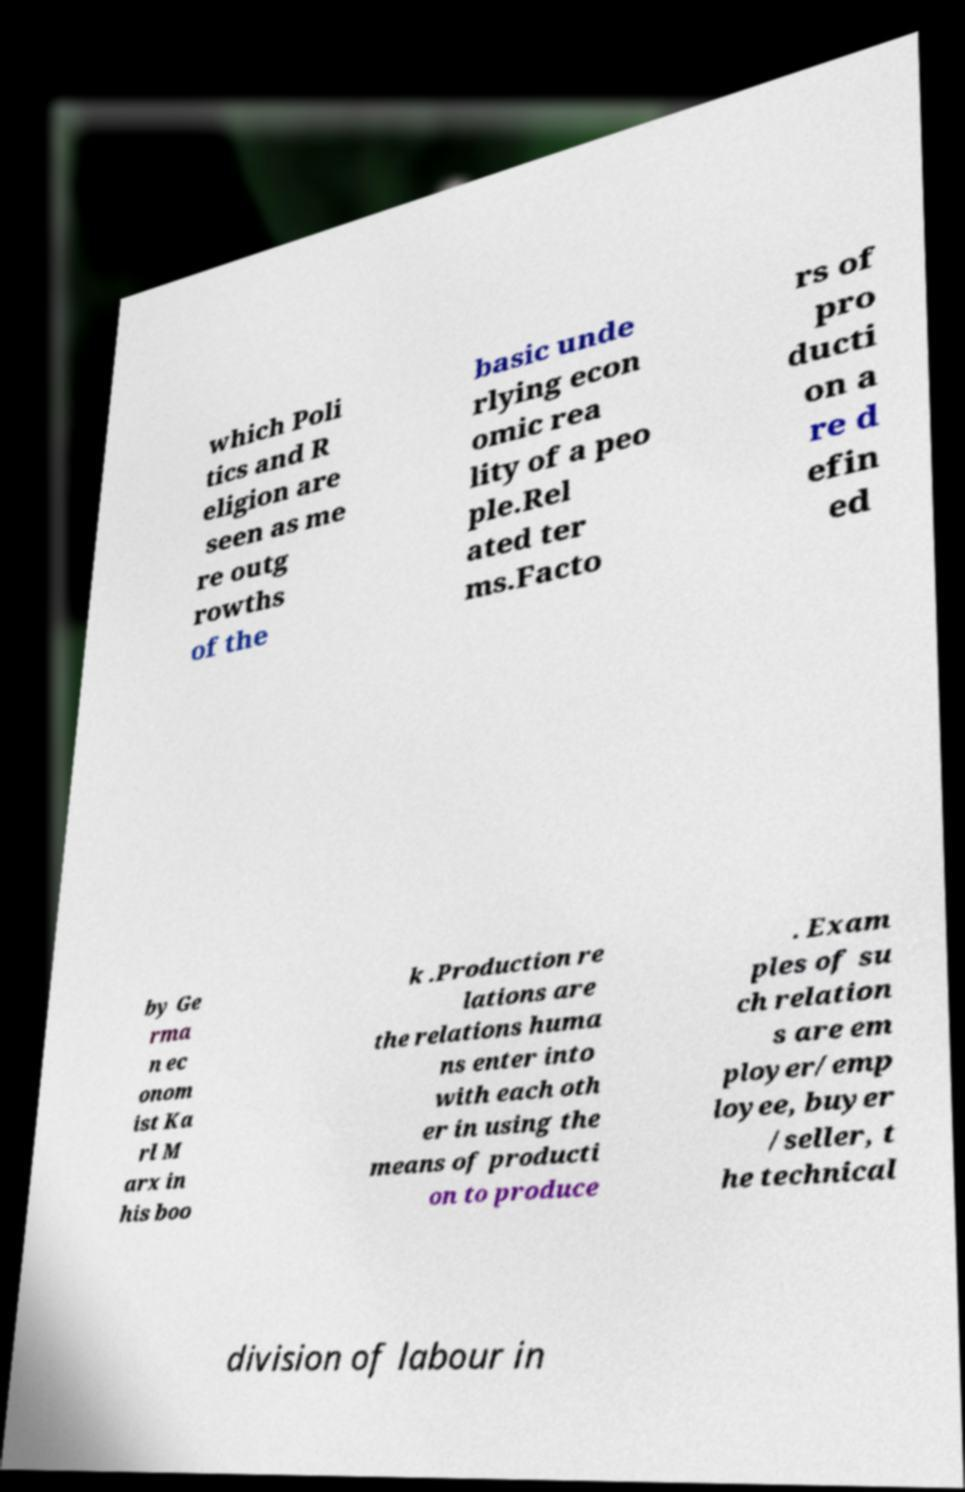I need the written content from this picture converted into text. Can you do that? which Poli tics and R eligion are seen as me re outg rowths of the basic unde rlying econ omic rea lity of a peo ple.Rel ated ter ms.Facto rs of pro ducti on a re d efin ed by Ge rma n ec onom ist Ka rl M arx in his boo k .Production re lations are the relations huma ns enter into with each oth er in using the means of producti on to produce . Exam ples of su ch relation s are em ployer/emp loyee, buyer /seller, t he technical division of labour in 